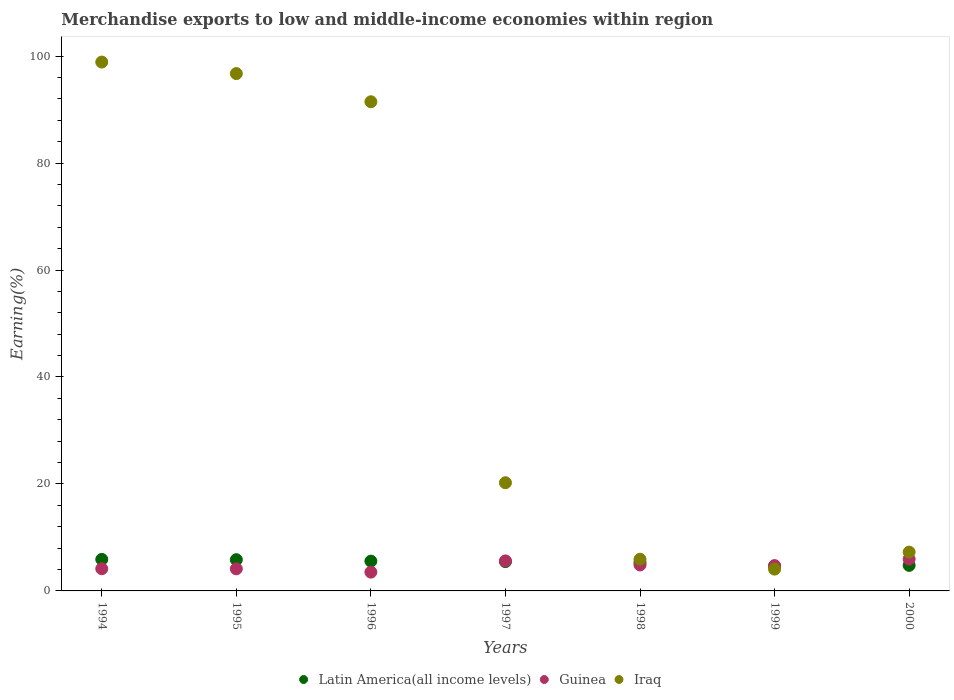Is the number of dotlines equal to the number of legend labels?
Make the answer very short. Yes. What is the percentage of amount earned from merchandise exports in Latin America(all income levels) in 1996?
Give a very brief answer. 5.57. Across all years, what is the maximum percentage of amount earned from merchandise exports in Latin America(all income levels)?
Ensure brevity in your answer.  5.89. Across all years, what is the minimum percentage of amount earned from merchandise exports in Latin America(all income levels)?
Provide a short and direct response. 4.6. What is the total percentage of amount earned from merchandise exports in Guinea in the graph?
Make the answer very short. 32.95. What is the difference between the percentage of amount earned from merchandise exports in Guinea in 1996 and that in 1997?
Your answer should be compact. -2.1. What is the difference between the percentage of amount earned from merchandise exports in Iraq in 1997 and the percentage of amount earned from merchandise exports in Guinea in 1999?
Provide a short and direct response. 15.49. What is the average percentage of amount earned from merchandise exports in Iraq per year?
Ensure brevity in your answer.  46.36. In the year 1996, what is the difference between the percentage of amount earned from merchandise exports in Guinea and percentage of amount earned from merchandise exports in Latin America(all income levels)?
Offer a very short reply. -2.06. What is the ratio of the percentage of amount earned from merchandise exports in Latin America(all income levels) in 1994 to that in 1998?
Your answer should be very brief. 1.11. What is the difference between the highest and the second highest percentage of amount earned from merchandise exports in Latin America(all income levels)?
Provide a short and direct response. 0.05. What is the difference between the highest and the lowest percentage of amount earned from merchandise exports in Iraq?
Give a very brief answer. 94.8. In how many years, is the percentage of amount earned from merchandise exports in Iraq greater than the average percentage of amount earned from merchandise exports in Iraq taken over all years?
Give a very brief answer. 3. Does the percentage of amount earned from merchandise exports in Iraq monotonically increase over the years?
Ensure brevity in your answer.  No. How many dotlines are there?
Offer a terse response. 3. Where does the legend appear in the graph?
Your response must be concise. Bottom center. How are the legend labels stacked?
Your response must be concise. Horizontal. What is the title of the graph?
Give a very brief answer. Merchandise exports to low and middle-income economies within region. What is the label or title of the Y-axis?
Give a very brief answer. Earning(%). What is the Earning(%) in Latin America(all income levels) in 1994?
Make the answer very short. 5.89. What is the Earning(%) of Guinea in 1994?
Offer a terse response. 4.15. What is the Earning(%) of Iraq in 1994?
Ensure brevity in your answer.  98.88. What is the Earning(%) of Latin America(all income levels) in 1995?
Provide a succinct answer. 5.84. What is the Earning(%) in Guinea in 1995?
Keep it short and to the point. 4.13. What is the Earning(%) in Iraq in 1995?
Offer a very short reply. 96.73. What is the Earning(%) of Latin America(all income levels) in 1996?
Provide a short and direct response. 5.57. What is the Earning(%) of Guinea in 1996?
Your answer should be compact. 3.51. What is the Earning(%) of Iraq in 1996?
Ensure brevity in your answer.  91.46. What is the Earning(%) of Latin America(all income levels) in 1997?
Keep it short and to the point. 5.48. What is the Earning(%) of Guinea in 1997?
Ensure brevity in your answer.  5.61. What is the Earning(%) in Iraq in 1997?
Provide a succinct answer. 20.23. What is the Earning(%) in Latin America(all income levels) in 1998?
Your response must be concise. 5.3. What is the Earning(%) of Guinea in 1998?
Make the answer very short. 4.85. What is the Earning(%) in Iraq in 1998?
Offer a very short reply. 5.93. What is the Earning(%) in Latin America(all income levels) in 1999?
Make the answer very short. 4.6. What is the Earning(%) in Guinea in 1999?
Keep it short and to the point. 4.74. What is the Earning(%) of Iraq in 1999?
Your response must be concise. 4.08. What is the Earning(%) in Latin America(all income levels) in 2000?
Make the answer very short. 4.78. What is the Earning(%) in Guinea in 2000?
Give a very brief answer. 5.96. What is the Earning(%) of Iraq in 2000?
Give a very brief answer. 7.26. Across all years, what is the maximum Earning(%) in Latin America(all income levels)?
Keep it short and to the point. 5.89. Across all years, what is the maximum Earning(%) of Guinea?
Provide a short and direct response. 5.96. Across all years, what is the maximum Earning(%) in Iraq?
Your answer should be compact. 98.88. Across all years, what is the minimum Earning(%) of Latin America(all income levels)?
Ensure brevity in your answer.  4.6. Across all years, what is the minimum Earning(%) in Guinea?
Provide a short and direct response. 3.51. Across all years, what is the minimum Earning(%) of Iraq?
Give a very brief answer. 4.08. What is the total Earning(%) of Latin America(all income levels) in the graph?
Provide a short and direct response. 37.46. What is the total Earning(%) of Guinea in the graph?
Give a very brief answer. 32.95. What is the total Earning(%) of Iraq in the graph?
Provide a short and direct response. 324.55. What is the difference between the Earning(%) in Latin America(all income levels) in 1994 and that in 1995?
Make the answer very short. 0.05. What is the difference between the Earning(%) in Guinea in 1994 and that in 1995?
Your answer should be very brief. 0.02. What is the difference between the Earning(%) of Iraq in 1994 and that in 1995?
Make the answer very short. 2.15. What is the difference between the Earning(%) in Latin America(all income levels) in 1994 and that in 1996?
Your response must be concise. 0.32. What is the difference between the Earning(%) in Guinea in 1994 and that in 1996?
Keep it short and to the point. 0.64. What is the difference between the Earning(%) of Iraq in 1994 and that in 1996?
Keep it short and to the point. 7.42. What is the difference between the Earning(%) in Latin America(all income levels) in 1994 and that in 1997?
Ensure brevity in your answer.  0.41. What is the difference between the Earning(%) in Guinea in 1994 and that in 1997?
Provide a succinct answer. -1.46. What is the difference between the Earning(%) in Iraq in 1994 and that in 1997?
Your answer should be compact. 78.65. What is the difference between the Earning(%) in Latin America(all income levels) in 1994 and that in 1998?
Your answer should be compact. 0.59. What is the difference between the Earning(%) of Guinea in 1994 and that in 1998?
Ensure brevity in your answer.  -0.7. What is the difference between the Earning(%) of Iraq in 1994 and that in 1998?
Offer a very short reply. 92.94. What is the difference between the Earning(%) of Latin America(all income levels) in 1994 and that in 1999?
Provide a short and direct response. 1.29. What is the difference between the Earning(%) in Guinea in 1994 and that in 1999?
Give a very brief answer. -0.59. What is the difference between the Earning(%) in Iraq in 1994 and that in 1999?
Offer a terse response. 94.8. What is the difference between the Earning(%) of Latin America(all income levels) in 1994 and that in 2000?
Provide a succinct answer. 1.11. What is the difference between the Earning(%) in Guinea in 1994 and that in 2000?
Make the answer very short. -1.81. What is the difference between the Earning(%) in Iraq in 1994 and that in 2000?
Give a very brief answer. 91.62. What is the difference between the Earning(%) of Latin America(all income levels) in 1995 and that in 1996?
Your answer should be very brief. 0.27. What is the difference between the Earning(%) in Guinea in 1995 and that in 1996?
Offer a very short reply. 0.62. What is the difference between the Earning(%) in Iraq in 1995 and that in 1996?
Your response must be concise. 5.27. What is the difference between the Earning(%) in Latin America(all income levels) in 1995 and that in 1997?
Ensure brevity in your answer.  0.36. What is the difference between the Earning(%) in Guinea in 1995 and that in 1997?
Ensure brevity in your answer.  -1.48. What is the difference between the Earning(%) of Iraq in 1995 and that in 1997?
Your answer should be compact. 76.5. What is the difference between the Earning(%) of Latin America(all income levels) in 1995 and that in 1998?
Your response must be concise. 0.54. What is the difference between the Earning(%) in Guinea in 1995 and that in 1998?
Give a very brief answer. -0.72. What is the difference between the Earning(%) in Iraq in 1995 and that in 1998?
Provide a short and direct response. 90.79. What is the difference between the Earning(%) of Latin America(all income levels) in 1995 and that in 1999?
Provide a short and direct response. 1.24. What is the difference between the Earning(%) of Guinea in 1995 and that in 1999?
Keep it short and to the point. -0.6. What is the difference between the Earning(%) in Iraq in 1995 and that in 1999?
Your answer should be very brief. 92.65. What is the difference between the Earning(%) in Latin America(all income levels) in 1995 and that in 2000?
Your response must be concise. 1.06. What is the difference between the Earning(%) of Guinea in 1995 and that in 2000?
Provide a short and direct response. -1.82. What is the difference between the Earning(%) of Iraq in 1995 and that in 2000?
Provide a short and direct response. 89.47. What is the difference between the Earning(%) in Latin America(all income levels) in 1996 and that in 1997?
Your answer should be compact. 0.09. What is the difference between the Earning(%) in Guinea in 1996 and that in 1997?
Give a very brief answer. -2.1. What is the difference between the Earning(%) of Iraq in 1996 and that in 1997?
Your answer should be very brief. 71.23. What is the difference between the Earning(%) of Latin America(all income levels) in 1996 and that in 1998?
Your answer should be compact. 0.27. What is the difference between the Earning(%) of Guinea in 1996 and that in 1998?
Your answer should be very brief. -1.34. What is the difference between the Earning(%) in Iraq in 1996 and that in 1998?
Your response must be concise. 85.52. What is the difference between the Earning(%) in Latin America(all income levels) in 1996 and that in 1999?
Offer a very short reply. 0.97. What is the difference between the Earning(%) of Guinea in 1996 and that in 1999?
Your response must be concise. -1.22. What is the difference between the Earning(%) in Iraq in 1996 and that in 1999?
Your answer should be very brief. 87.38. What is the difference between the Earning(%) in Latin America(all income levels) in 1996 and that in 2000?
Your answer should be compact. 0.79. What is the difference between the Earning(%) of Guinea in 1996 and that in 2000?
Offer a very short reply. -2.44. What is the difference between the Earning(%) in Iraq in 1996 and that in 2000?
Offer a very short reply. 84.2. What is the difference between the Earning(%) of Latin America(all income levels) in 1997 and that in 1998?
Offer a terse response. 0.18. What is the difference between the Earning(%) of Guinea in 1997 and that in 1998?
Your response must be concise. 0.76. What is the difference between the Earning(%) of Iraq in 1997 and that in 1998?
Your response must be concise. 14.29. What is the difference between the Earning(%) of Latin America(all income levels) in 1997 and that in 1999?
Your response must be concise. 0.88. What is the difference between the Earning(%) of Guinea in 1997 and that in 1999?
Give a very brief answer. 0.87. What is the difference between the Earning(%) in Iraq in 1997 and that in 1999?
Provide a succinct answer. 16.15. What is the difference between the Earning(%) of Latin America(all income levels) in 1997 and that in 2000?
Provide a succinct answer. 0.7. What is the difference between the Earning(%) in Guinea in 1997 and that in 2000?
Provide a short and direct response. -0.35. What is the difference between the Earning(%) of Iraq in 1997 and that in 2000?
Your answer should be compact. 12.97. What is the difference between the Earning(%) in Latin America(all income levels) in 1998 and that in 1999?
Give a very brief answer. 0.7. What is the difference between the Earning(%) of Guinea in 1998 and that in 1999?
Your answer should be very brief. 0.11. What is the difference between the Earning(%) in Iraq in 1998 and that in 1999?
Your response must be concise. 1.85. What is the difference between the Earning(%) of Latin America(all income levels) in 1998 and that in 2000?
Your answer should be very brief. 0.52. What is the difference between the Earning(%) in Guinea in 1998 and that in 2000?
Offer a very short reply. -1.11. What is the difference between the Earning(%) of Iraq in 1998 and that in 2000?
Ensure brevity in your answer.  -1.32. What is the difference between the Earning(%) in Latin America(all income levels) in 1999 and that in 2000?
Keep it short and to the point. -0.18. What is the difference between the Earning(%) in Guinea in 1999 and that in 2000?
Offer a very short reply. -1.22. What is the difference between the Earning(%) of Iraq in 1999 and that in 2000?
Ensure brevity in your answer.  -3.18. What is the difference between the Earning(%) of Latin America(all income levels) in 1994 and the Earning(%) of Guinea in 1995?
Offer a very short reply. 1.76. What is the difference between the Earning(%) in Latin America(all income levels) in 1994 and the Earning(%) in Iraq in 1995?
Keep it short and to the point. -90.83. What is the difference between the Earning(%) of Guinea in 1994 and the Earning(%) of Iraq in 1995?
Provide a short and direct response. -92.58. What is the difference between the Earning(%) in Latin America(all income levels) in 1994 and the Earning(%) in Guinea in 1996?
Provide a short and direct response. 2.38. What is the difference between the Earning(%) in Latin America(all income levels) in 1994 and the Earning(%) in Iraq in 1996?
Provide a succinct answer. -85.56. What is the difference between the Earning(%) of Guinea in 1994 and the Earning(%) of Iraq in 1996?
Provide a succinct answer. -87.31. What is the difference between the Earning(%) of Latin America(all income levels) in 1994 and the Earning(%) of Guinea in 1997?
Provide a short and direct response. 0.28. What is the difference between the Earning(%) in Latin America(all income levels) in 1994 and the Earning(%) in Iraq in 1997?
Provide a short and direct response. -14.33. What is the difference between the Earning(%) in Guinea in 1994 and the Earning(%) in Iraq in 1997?
Keep it short and to the point. -16.08. What is the difference between the Earning(%) in Latin America(all income levels) in 1994 and the Earning(%) in Guinea in 1998?
Ensure brevity in your answer.  1.04. What is the difference between the Earning(%) in Latin America(all income levels) in 1994 and the Earning(%) in Iraq in 1998?
Your response must be concise. -0.04. What is the difference between the Earning(%) of Guinea in 1994 and the Earning(%) of Iraq in 1998?
Keep it short and to the point. -1.78. What is the difference between the Earning(%) in Latin America(all income levels) in 1994 and the Earning(%) in Guinea in 1999?
Your response must be concise. 1.16. What is the difference between the Earning(%) in Latin America(all income levels) in 1994 and the Earning(%) in Iraq in 1999?
Provide a succinct answer. 1.81. What is the difference between the Earning(%) in Guinea in 1994 and the Earning(%) in Iraq in 1999?
Your response must be concise. 0.07. What is the difference between the Earning(%) of Latin America(all income levels) in 1994 and the Earning(%) of Guinea in 2000?
Your response must be concise. -0.06. What is the difference between the Earning(%) in Latin America(all income levels) in 1994 and the Earning(%) in Iraq in 2000?
Offer a very short reply. -1.37. What is the difference between the Earning(%) in Guinea in 1994 and the Earning(%) in Iraq in 2000?
Provide a succinct answer. -3.11. What is the difference between the Earning(%) of Latin America(all income levels) in 1995 and the Earning(%) of Guinea in 1996?
Your answer should be compact. 2.33. What is the difference between the Earning(%) in Latin America(all income levels) in 1995 and the Earning(%) in Iraq in 1996?
Provide a succinct answer. -85.62. What is the difference between the Earning(%) of Guinea in 1995 and the Earning(%) of Iraq in 1996?
Your answer should be very brief. -87.32. What is the difference between the Earning(%) of Latin America(all income levels) in 1995 and the Earning(%) of Guinea in 1997?
Ensure brevity in your answer.  0.23. What is the difference between the Earning(%) of Latin America(all income levels) in 1995 and the Earning(%) of Iraq in 1997?
Offer a very short reply. -14.39. What is the difference between the Earning(%) in Guinea in 1995 and the Earning(%) in Iraq in 1997?
Provide a succinct answer. -16.09. What is the difference between the Earning(%) in Latin America(all income levels) in 1995 and the Earning(%) in Guinea in 1998?
Offer a very short reply. 0.99. What is the difference between the Earning(%) of Latin America(all income levels) in 1995 and the Earning(%) of Iraq in 1998?
Your answer should be compact. -0.09. What is the difference between the Earning(%) in Guinea in 1995 and the Earning(%) in Iraq in 1998?
Offer a terse response. -1.8. What is the difference between the Earning(%) of Latin America(all income levels) in 1995 and the Earning(%) of Guinea in 1999?
Provide a short and direct response. 1.1. What is the difference between the Earning(%) of Latin America(all income levels) in 1995 and the Earning(%) of Iraq in 1999?
Provide a short and direct response. 1.76. What is the difference between the Earning(%) in Guinea in 1995 and the Earning(%) in Iraq in 1999?
Give a very brief answer. 0.05. What is the difference between the Earning(%) in Latin America(all income levels) in 1995 and the Earning(%) in Guinea in 2000?
Offer a very short reply. -0.12. What is the difference between the Earning(%) in Latin America(all income levels) in 1995 and the Earning(%) in Iraq in 2000?
Offer a terse response. -1.42. What is the difference between the Earning(%) of Guinea in 1995 and the Earning(%) of Iraq in 2000?
Offer a terse response. -3.12. What is the difference between the Earning(%) in Latin America(all income levels) in 1996 and the Earning(%) in Guinea in 1997?
Keep it short and to the point. -0.04. What is the difference between the Earning(%) in Latin America(all income levels) in 1996 and the Earning(%) in Iraq in 1997?
Ensure brevity in your answer.  -14.66. What is the difference between the Earning(%) in Guinea in 1996 and the Earning(%) in Iraq in 1997?
Your answer should be compact. -16.71. What is the difference between the Earning(%) of Latin America(all income levels) in 1996 and the Earning(%) of Guinea in 1998?
Ensure brevity in your answer.  0.72. What is the difference between the Earning(%) in Latin America(all income levels) in 1996 and the Earning(%) in Iraq in 1998?
Your response must be concise. -0.37. What is the difference between the Earning(%) of Guinea in 1996 and the Earning(%) of Iraq in 1998?
Provide a succinct answer. -2.42. What is the difference between the Earning(%) in Latin America(all income levels) in 1996 and the Earning(%) in Guinea in 1999?
Your response must be concise. 0.83. What is the difference between the Earning(%) in Latin America(all income levels) in 1996 and the Earning(%) in Iraq in 1999?
Your response must be concise. 1.49. What is the difference between the Earning(%) of Guinea in 1996 and the Earning(%) of Iraq in 1999?
Your answer should be compact. -0.57. What is the difference between the Earning(%) in Latin America(all income levels) in 1996 and the Earning(%) in Guinea in 2000?
Provide a succinct answer. -0.39. What is the difference between the Earning(%) of Latin America(all income levels) in 1996 and the Earning(%) of Iraq in 2000?
Offer a very short reply. -1.69. What is the difference between the Earning(%) in Guinea in 1996 and the Earning(%) in Iraq in 2000?
Your answer should be very brief. -3.75. What is the difference between the Earning(%) of Latin America(all income levels) in 1997 and the Earning(%) of Guinea in 1998?
Ensure brevity in your answer.  0.63. What is the difference between the Earning(%) in Latin America(all income levels) in 1997 and the Earning(%) in Iraq in 1998?
Provide a short and direct response. -0.46. What is the difference between the Earning(%) of Guinea in 1997 and the Earning(%) of Iraq in 1998?
Ensure brevity in your answer.  -0.32. What is the difference between the Earning(%) of Latin America(all income levels) in 1997 and the Earning(%) of Guinea in 1999?
Make the answer very short. 0.74. What is the difference between the Earning(%) of Latin America(all income levels) in 1997 and the Earning(%) of Iraq in 1999?
Your answer should be compact. 1.4. What is the difference between the Earning(%) of Guinea in 1997 and the Earning(%) of Iraq in 1999?
Make the answer very short. 1.53. What is the difference between the Earning(%) of Latin America(all income levels) in 1997 and the Earning(%) of Guinea in 2000?
Give a very brief answer. -0.48. What is the difference between the Earning(%) of Latin America(all income levels) in 1997 and the Earning(%) of Iraq in 2000?
Provide a short and direct response. -1.78. What is the difference between the Earning(%) in Guinea in 1997 and the Earning(%) in Iraq in 2000?
Ensure brevity in your answer.  -1.65. What is the difference between the Earning(%) in Latin America(all income levels) in 1998 and the Earning(%) in Guinea in 1999?
Offer a very short reply. 0.57. What is the difference between the Earning(%) of Latin America(all income levels) in 1998 and the Earning(%) of Iraq in 1999?
Keep it short and to the point. 1.22. What is the difference between the Earning(%) in Guinea in 1998 and the Earning(%) in Iraq in 1999?
Keep it short and to the point. 0.77. What is the difference between the Earning(%) of Latin America(all income levels) in 1998 and the Earning(%) of Guinea in 2000?
Keep it short and to the point. -0.65. What is the difference between the Earning(%) in Latin America(all income levels) in 1998 and the Earning(%) in Iraq in 2000?
Make the answer very short. -1.95. What is the difference between the Earning(%) of Guinea in 1998 and the Earning(%) of Iraq in 2000?
Ensure brevity in your answer.  -2.41. What is the difference between the Earning(%) of Latin America(all income levels) in 1999 and the Earning(%) of Guinea in 2000?
Offer a very short reply. -1.36. What is the difference between the Earning(%) in Latin America(all income levels) in 1999 and the Earning(%) in Iraq in 2000?
Your answer should be very brief. -2.66. What is the difference between the Earning(%) in Guinea in 1999 and the Earning(%) in Iraq in 2000?
Provide a succinct answer. -2.52. What is the average Earning(%) of Latin America(all income levels) per year?
Make the answer very short. 5.35. What is the average Earning(%) in Guinea per year?
Your response must be concise. 4.71. What is the average Earning(%) in Iraq per year?
Give a very brief answer. 46.36. In the year 1994, what is the difference between the Earning(%) of Latin America(all income levels) and Earning(%) of Guinea?
Offer a very short reply. 1.74. In the year 1994, what is the difference between the Earning(%) in Latin America(all income levels) and Earning(%) in Iraq?
Give a very brief answer. -92.98. In the year 1994, what is the difference between the Earning(%) in Guinea and Earning(%) in Iraq?
Provide a short and direct response. -94.73. In the year 1995, what is the difference between the Earning(%) in Latin America(all income levels) and Earning(%) in Guinea?
Your answer should be very brief. 1.71. In the year 1995, what is the difference between the Earning(%) in Latin America(all income levels) and Earning(%) in Iraq?
Provide a short and direct response. -90.89. In the year 1995, what is the difference between the Earning(%) of Guinea and Earning(%) of Iraq?
Offer a very short reply. -92.59. In the year 1996, what is the difference between the Earning(%) in Latin America(all income levels) and Earning(%) in Guinea?
Your response must be concise. 2.06. In the year 1996, what is the difference between the Earning(%) in Latin America(all income levels) and Earning(%) in Iraq?
Give a very brief answer. -85.89. In the year 1996, what is the difference between the Earning(%) in Guinea and Earning(%) in Iraq?
Ensure brevity in your answer.  -87.94. In the year 1997, what is the difference between the Earning(%) of Latin America(all income levels) and Earning(%) of Guinea?
Your response must be concise. -0.13. In the year 1997, what is the difference between the Earning(%) of Latin America(all income levels) and Earning(%) of Iraq?
Keep it short and to the point. -14.75. In the year 1997, what is the difference between the Earning(%) in Guinea and Earning(%) in Iraq?
Keep it short and to the point. -14.62. In the year 1998, what is the difference between the Earning(%) in Latin America(all income levels) and Earning(%) in Guinea?
Give a very brief answer. 0.45. In the year 1998, what is the difference between the Earning(%) of Latin America(all income levels) and Earning(%) of Iraq?
Provide a succinct answer. -0.63. In the year 1998, what is the difference between the Earning(%) in Guinea and Earning(%) in Iraq?
Your answer should be very brief. -1.08. In the year 1999, what is the difference between the Earning(%) in Latin America(all income levels) and Earning(%) in Guinea?
Your answer should be very brief. -0.14. In the year 1999, what is the difference between the Earning(%) of Latin America(all income levels) and Earning(%) of Iraq?
Give a very brief answer. 0.52. In the year 1999, what is the difference between the Earning(%) in Guinea and Earning(%) in Iraq?
Your answer should be compact. 0.66. In the year 2000, what is the difference between the Earning(%) in Latin America(all income levels) and Earning(%) in Guinea?
Give a very brief answer. -1.18. In the year 2000, what is the difference between the Earning(%) of Latin America(all income levels) and Earning(%) of Iraq?
Make the answer very short. -2.48. In the year 2000, what is the difference between the Earning(%) in Guinea and Earning(%) in Iraq?
Your answer should be compact. -1.3. What is the ratio of the Earning(%) of Latin America(all income levels) in 1994 to that in 1995?
Your answer should be compact. 1.01. What is the ratio of the Earning(%) of Iraq in 1994 to that in 1995?
Your answer should be very brief. 1.02. What is the ratio of the Earning(%) in Latin America(all income levels) in 1994 to that in 1996?
Offer a very short reply. 1.06. What is the ratio of the Earning(%) in Guinea in 1994 to that in 1996?
Offer a very short reply. 1.18. What is the ratio of the Earning(%) in Iraq in 1994 to that in 1996?
Provide a short and direct response. 1.08. What is the ratio of the Earning(%) of Latin America(all income levels) in 1994 to that in 1997?
Provide a short and direct response. 1.08. What is the ratio of the Earning(%) in Guinea in 1994 to that in 1997?
Offer a very short reply. 0.74. What is the ratio of the Earning(%) in Iraq in 1994 to that in 1997?
Offer a terse response. 4.89. What is the ratio of the Earning(%) of Latin America(all income levels) in 1994 to that in 1998?
Your response must be concise. 1.11. What is the ratio of the Earning(%) of Guinea in 1994 to that in 1998?
Give a very brief answer. 0.86. What is the ratio of the Earning(%) in Iraq in 1994 to that in 1998?
Provide a short and direct response. 16.66. What is the ratio of the Earning(%) in Latin America(all income levels) in 1994 to that in 1999?
Make the answer very short. 1.28. What is the ratio of the Earning(%) of Guinea in 1994 to that in 1999?
Keep it short and to the point. 0.88. What is the ratio of the Earning(%) of Iraq in 1994 to that in 1999?
Offer a terse response. 24.23. What is the ratio of the Earning(%) of Latin America(all income levels) in 1994 to that in 2000?
Keep it short and to the point. 1.23. What is the ratio of the Earning(%) of Guinea in 1994 to that in 2000?
Your answer should be very brief. 0.7. What is the ratio of the Earning(%) in Iraq in 1994 to that in 2000?
Give a very brief answer. 13.63. What is the ratio of the Earning(%) of Latin America(all income levels) in 1995 to that in 1996?
Your answer should be compact. 1.05. What is the ratio of the Earning(%) of Guinea in 1995 to that in 1996?
Provide a short and direct response. 1.18. What is the ratio of the Earning(%) of Iraq in 1995 to that in 1996?
Keep it short and to the point. 1.06. What is the ratio of the Earning(%) of Latin America(all income levels) in 1995 to that in 1997?
Ensure brevity in your answer.  1.07. What is the ratio of the Earning(%) of Guinea in 1995 to that in 1997?
Provide a succinct answer. 0.74. What is the ratio of the Earning(%) in Iraq in 1995 to that in 1997?
Provide a succinct answer. 4.78. What is the ratio of the Earning(%) in Latin America(all income levels) in 1995 to that in 1998?
Make the answer very short. 1.1. What is the ratio of the Earning(%) of Guinea in 1995 to that in 1998?
Offer a very short reply. 0.85. What is the ratio of the Earning(%) in Iraq in 1995 to that in 1998?
Your answer should be compact. 16.3. What is the ratio of the Earning(%) in Latin America(all income levels) in 1995 to that in 1999?
Your answer should be very brief. 1.27. What is the ratio of the Earning(%) in Guinea in 1995 to that in 1999?
Provide a short and direct response. 0.87. What is the ratio of the Earning(%) in Iraq in 1995 to that in 1999?
Offer a terse response. 23.71. What is the ratio of the Earning(%) in Latin America(all income levels) in 1995 to that in 2000?
Your response must be concise. 1.22. What is the ratio of the Earning(%) of Guinea in 1995 to that in 2000?
Provide a short and direct response. 0.69. What is the ratio of the Earning(%) in Iraq in 1995 to that in 2000?
Your response must be concise. 13.33. What is the ratio of the Earning(%) in Latin America(all income levels) in 1996 to that in 1997?
Provide a short and direct response. 1.02. What is the ratio of the Earning(%) of Guinea in 1996 to that in 1997?
Offer a very short reply. 0.63. What is the ratio of the Earning(%) of Iraq in 1996 to that in 1997?
Offer a very short reply. 4.52. What is the ratio of the Earning(%) of Guinea in 1996 to that in 1998?
Your answer should be very brief. 0.72. What is the ratio of the Earning(%) of Iraq in 1996 to that in 1998?
Ensure brevity in your answer.  15.41. What is the ratio of the Earning(%) in Latin America(all income levels) in 1996 to that in 1999?
Make the answer very short. 1.21. What is the ratio of the Earning(%) of Guinea in 1996 to that in 1999?
Give a very brief answer. 0.74. What is the ratio of the Earning(%) of Iraq in 1996 to that in 1999?
Make the answer very short. 22.42. What is the ratio of the Earning(%) of Latin America(all income levels) in 1996 to that in 2000?
Offer a terse response. 1.17. What is the ratio of the Earning(%) of Guinea in 1996 to that in 2000?
Ensure brevity in your answer.  0.59. What is the ratio of the Earning(%) of Iraq in 1996 to that in 2000?
Keep it short and to the point. 12.6. What is the ratio of the Earning(%) of Latin America(all income levels) in 1997 to that in 1998?
Offer a terse response. 1.03. What is the ratio of the Earning(%) of Guinea in 1997 to that in 1998?
Your answer should be compact. 1.16. What is the ratio of the Earning(%) in Iraq in 1997 to that in 1998?
Offer a terse response. 3.41. What is the ratio of the Earning(%) in Latin America(all income levels) in 1997 to that in 1999?
Offer a terse response. 1.19. What is the ratio of the Earning(%) in Guinea in 1997 to that in 1999?
Offer a terse response. 1.18. What is the ratio of the Earning(%) of Iraq in 1997 to that in 1999?
Your answer should be compact. 4.96. What is the ratio of the Earning(%) of Latin America(all income levels) in 1997 to that in 2000?
Your answer should be very brief. 1.15. What is the ratio of the Earning(%) in Guinea in 1997 to that in 2000?
Provide a short and direct response. 0.94. What is the ratio of the Earning(%) in Iraq in 1997 to that in 2000?
Your answer should be very brief. 2.79. What is the ratio of the Earning(%) of Latin America(all income levels) in 1998 to that in 1999?
Give a very brief answer. 1.15. What is the ratio of the Earning(%) in Guinea in 1998 to that in 1999?
Your answer should be compact. 1.02. What is the ratio of the Earning(%) in Iraq in 1998 to that in 1999?
Keep it short and to the point. 1.45. What is the ratio of the Earning(%) in Latin America(all income levels) in 1998 to that in 2000?
Ensure brevity in your answer.  1.11. What is the ratio of the Earning(%) of Guinea in 1998 to that in 2000?
Provide a short and direct response. 0.81. What is the ratio of the Earning(%) in Iraq in 1998 to that in 2000?
Your response must be concise. 0.82. What is the ratio of the Earning(%) of Latin America(all income levels) in 1999 to that in 2000?
Ensure brevity in your answer.  0.96. What is the ratio of the Earning(%) in Guinea in 1999 to that in 2000?
Offer a terse response. 0.8. What is the ratio of the Earning(%) of Iraq in 1999 to that in 2000?
Offer a terse response. 0.56. What is the difference between the highest and the second highest Earning(%) in Latin America(all income levels)?
Your response must be concise. 0.05. What is the difference between the highest and the second highest Earning(%) of Guinea?
Make the answer very short. 0.35. What is the difference between the highest and the second highest Earning(%) of Iraq?
Your response must be concise. 2.15. What is the difference between the highest and the lowest Earning(%) of Latin America(all income levels)?
Make the answer very short. 1.29. What is the difference between the highest and the lowest Earning(%) of Guinea?
Your response must be concise. 2.44. What is the difference between the highest and the lowest Earning(%) of Iraq?
Give a very brief answer. 94.8. 